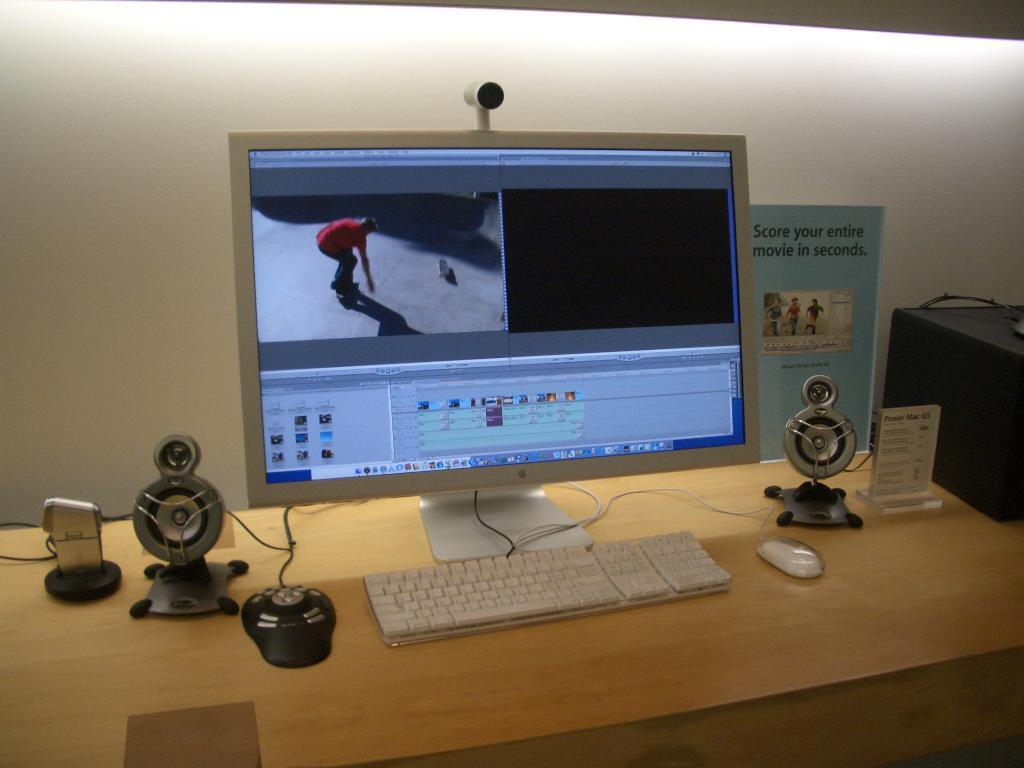<image>
Summarize the visual content of the image. A computer screen next to a sign that says you can Score your entire movie in seconds. 